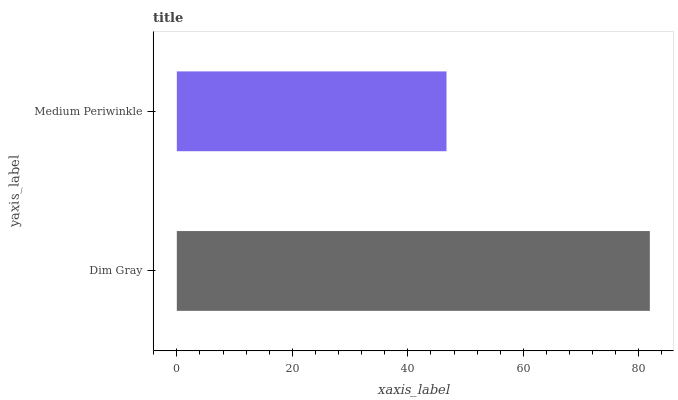Is Medium Periwinkle the minimum?
Answer yes or no. Yes. Is Dim Gray the maximum?
Answer yes or no. Yes. Is Medium Periwinkle the maximum?
Answer yes or no. No. Is Dim Gray greater than Medium Periwinkle?
Answer yes or no. Yes. Is Medium Periwinkle less than Dim Gray?
Answer yes or no. Yes. Is Medium Periwinkle greater than Dim Gray?
Answer yes or no. No. Is Dim Gray less than Medium Periwinkle?
Answer yes or no. No. Is Dim Gray the high median?
Answer yes or no. Yes. Is Medium Periwinkle the low median?
Answer yes or no. Yes. Is Medium Periwinkle the high median?
Answer yes or no. No. Is Dim Gray the low median?
Answer yes or no. No. 